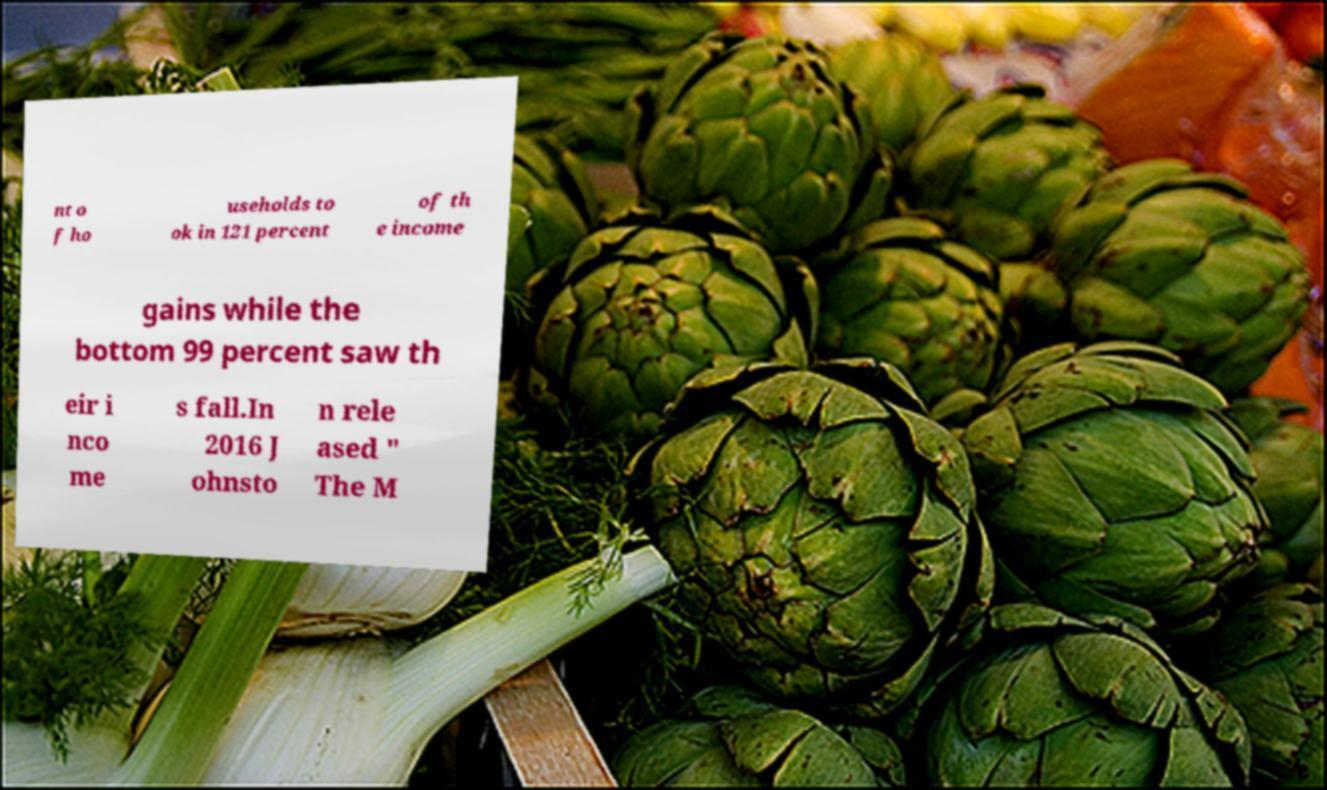What messages or text are displayed in this image? I need them in a readable, typed format. nt o f ho useholds to ok in 121 percent of th e income gains while the bottom 99 percent saw th eir i nco me s fall.In 2016 J ohnsto n rele ased " The M 